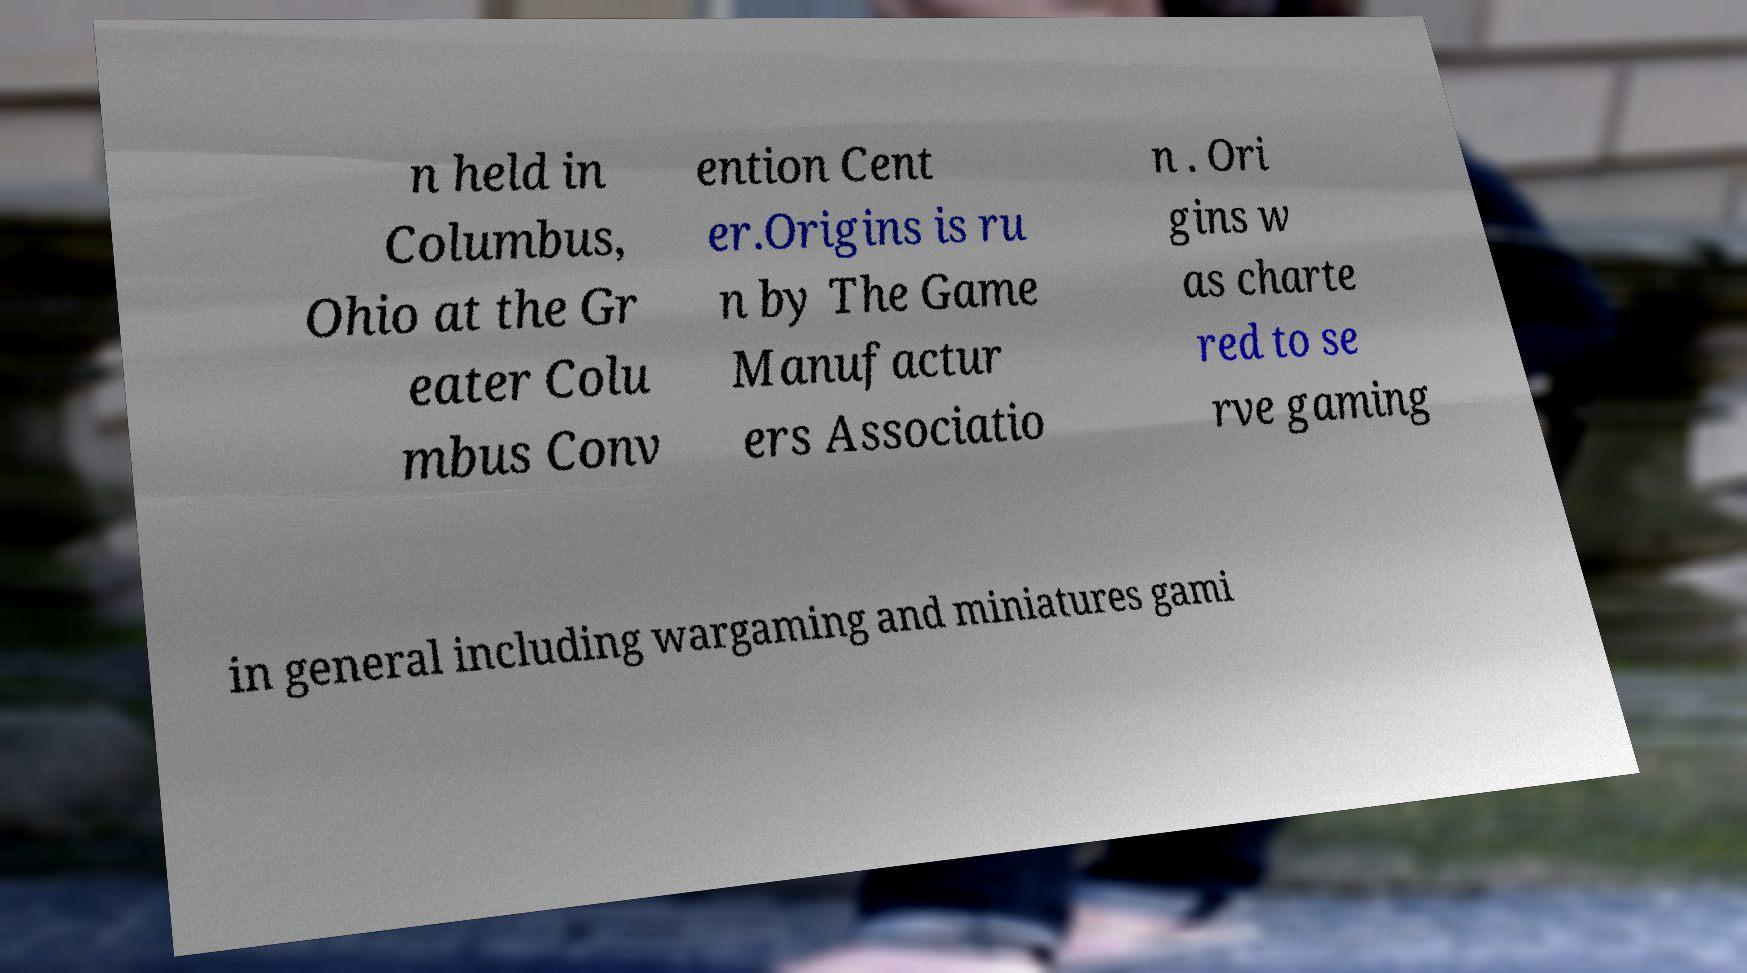There's text embedded in this image that I need extracted. Can you transcribe it verbatim? n held in Columbus, Ohio at the Gr eater Colu mbus Conv ention Cent er.Origins is ru n by The Game Manufactur ers Associatio n . Ori gins w as charte red to se rve gaming in general including wargaming and miniatures gami 